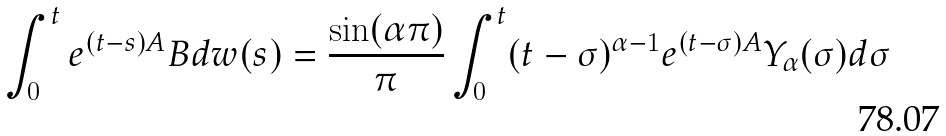Convert formula to latex. <formula><loc_0><loc_0><loc_500><loc_500>\int _ { 0 } ^ { t } e ^ { ( t - s ) A } B d w ( s ) = \frac { \sin ( \alpha \pi ) } { \pi } \int _ { 0 } ^ { t } ( t - \sigma ) ^ { \alpha - 1 } e ^ { ( t - \sigma ) A } Y _ { \alpha } ( \sigma ) d \sigma</formula> 